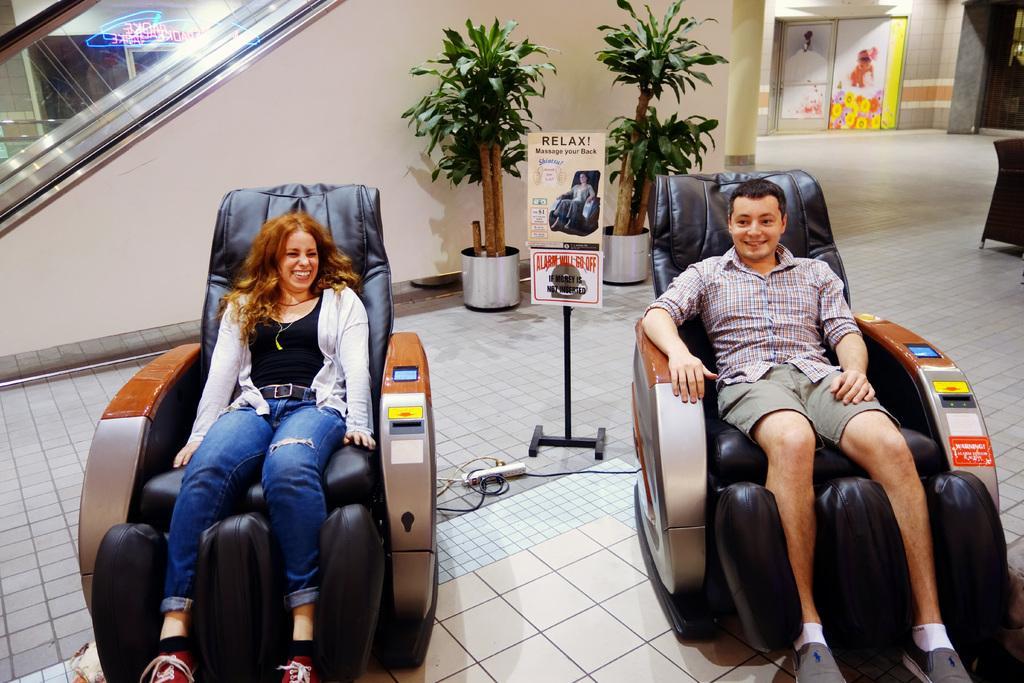Can you describe this image briefly? In the middle of the image there is a banner and there are two plants and there are two chairs on the chairs two persons are sitting and smiling. Top right side of the image there is a wall. Top left side of the image there is a staircase. 